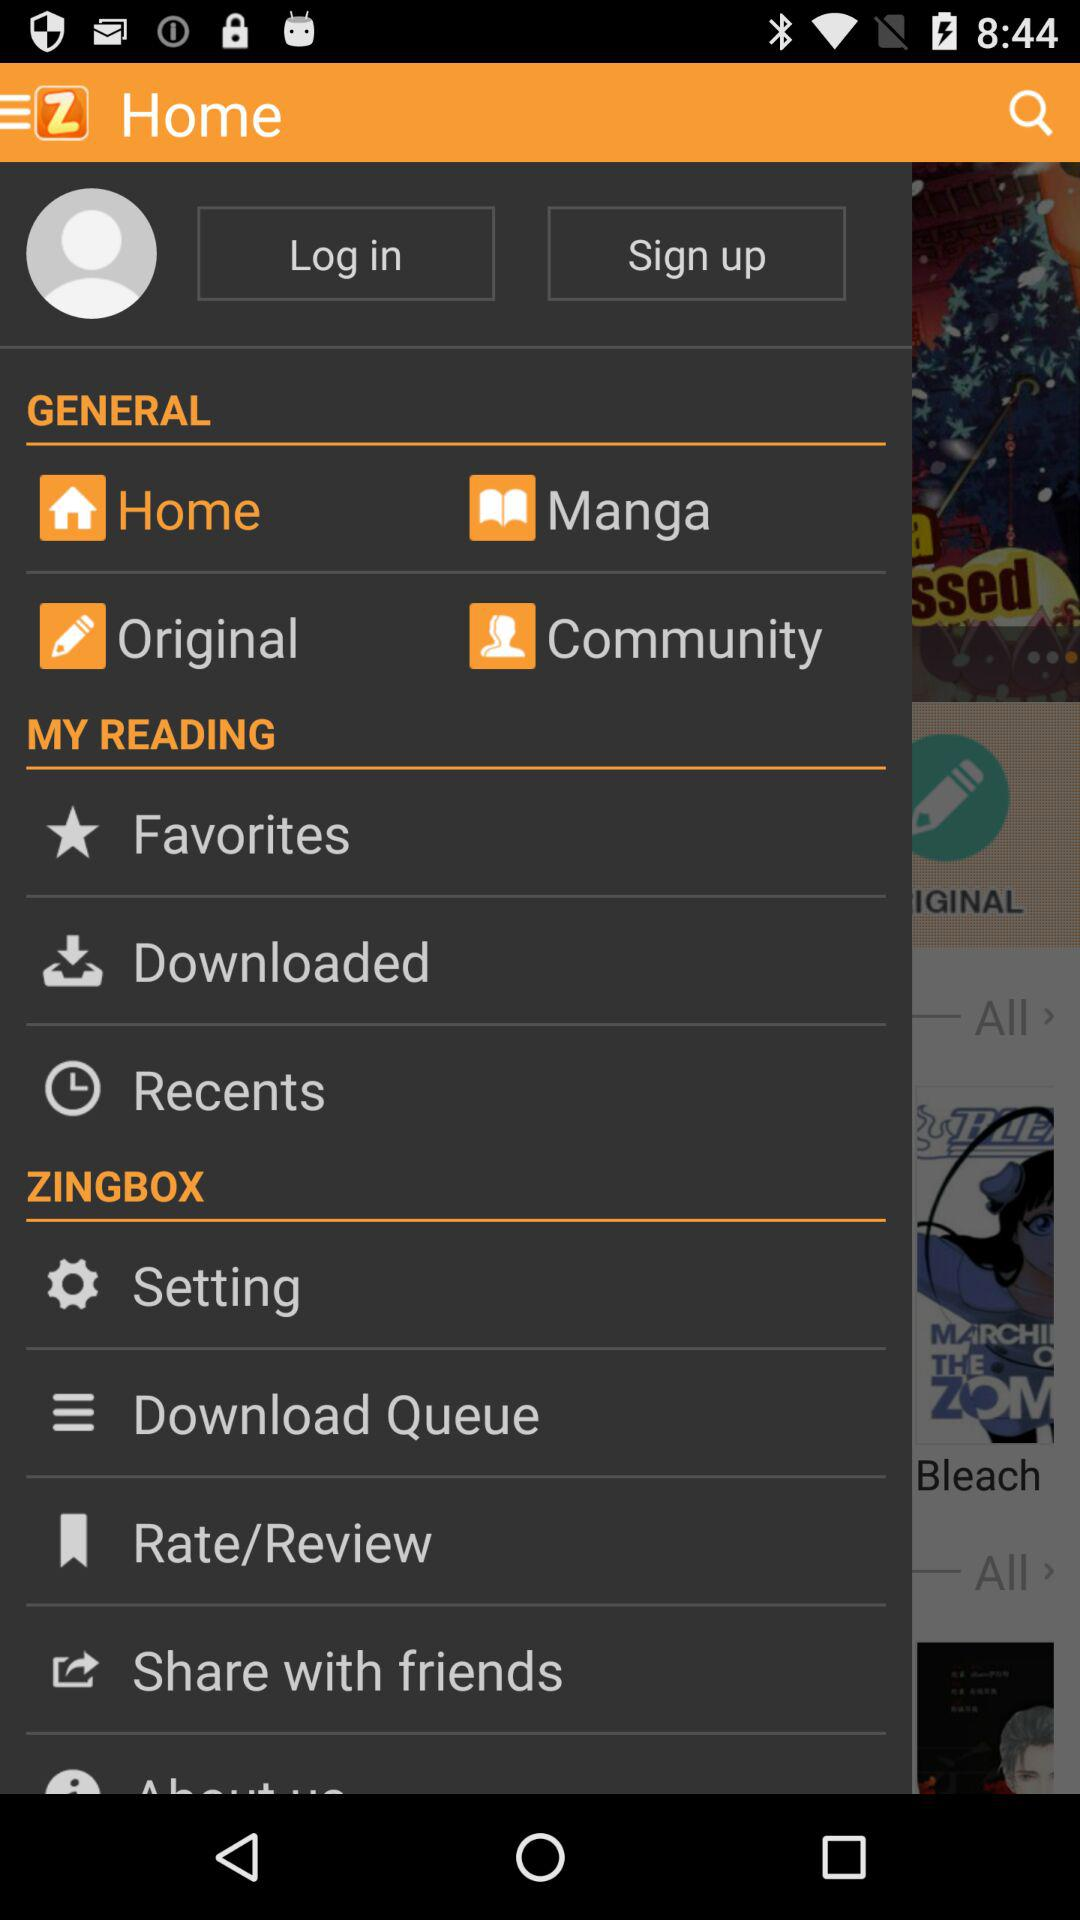How many items are in the 'My Reading' section?
Answer the question using a single word or phrase. 3 